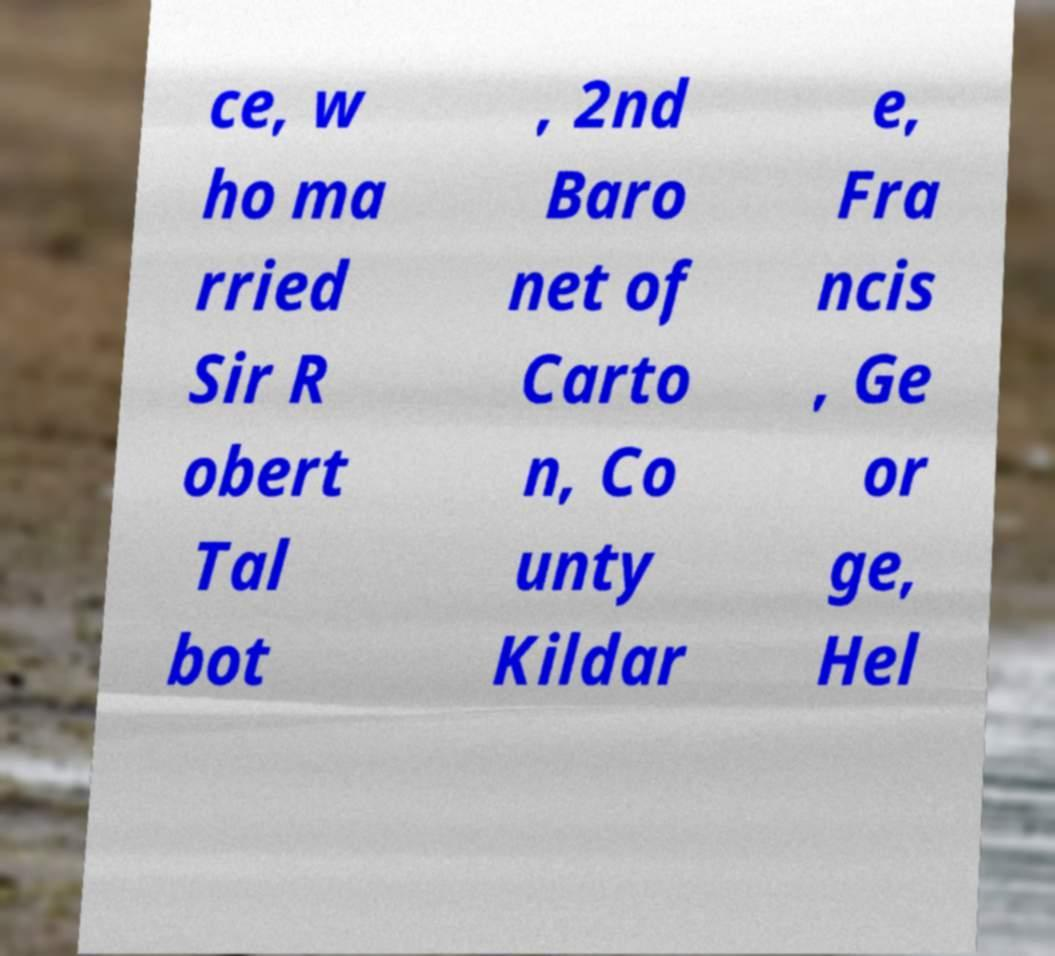Please read and relay the text visible in this image. What does it say? ce, w ho ma rried Sir R obert Tal bot , 2nd Baro net of Carto n, Co unty Kildar e, Fra ncis , Ge or ge, Hel 